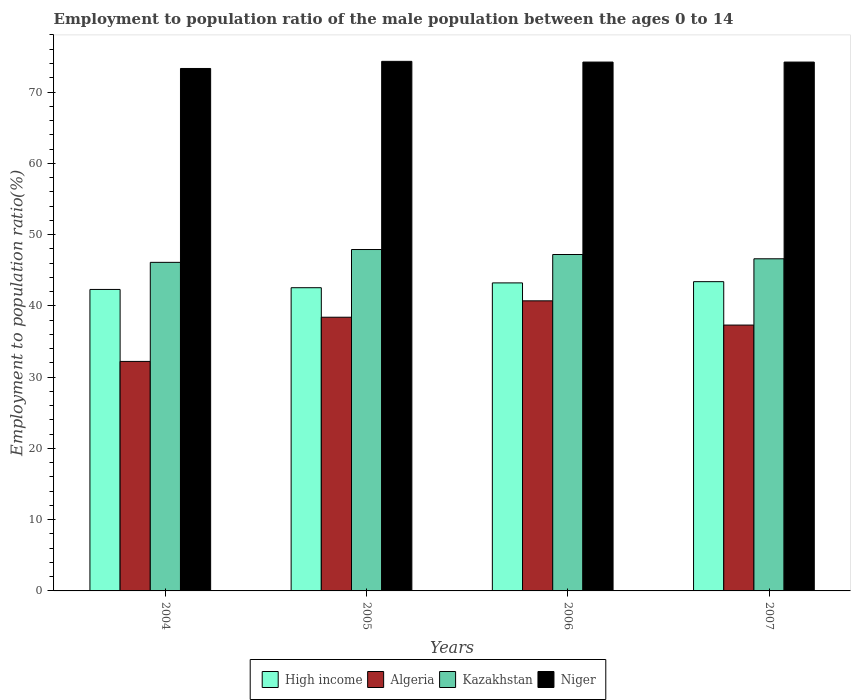How many groups of bars are there?
Provide a short and direct response. 4. Are the number of bars on each tick of the X-axis equal?
Provide a succinct answer. Yes. How many bars are there on the 1st tick from the left?
Provide a short and direct response. 4. How many bars are there on the 1st tick from the right?
Your answer should be compact. 4. In how many cases, is the number of bars for a given year not equal to the number of legend labels?
Provide a succinct answer. 0. What is the employment to population ratio in Kazakhstan in 2007?
Ensure brevity in your answer.  46.6. Across all years, what is the maximum employment to population ratio in Algeria?
Your answer should be very brief. 40.7. Across all years, what is the minimum employment to population ratio in Algeria?
Your answer should be compact. 32.2. In which year was the employment to population ratio in Algeria minimum?
Give a very brief answer. 2004. What is the total employment to population ratio in High income in the graph?
Ensure brevity in your answer.  171.44. What is the difference between the employment to population ratio in High income in 2006 and that in 2007?
Your answer should be compact. -0.17. What is the difference between the employment to population ratio in High income in 2007 and the employment to population ratio in Niger in 2005?
Provide a short and direct response. -30.91. What is the average employment to population ratio in Niger per year?
Keep it short and to the point. 74. In the year 2006, what is the difference between the employment to population ratio in High income and employment to population ratio in Niger?
Provide a short and direct response. -30.98. In how many years, is the employment to population ratio in Niger greater than 36 %?
Keep it short and to the point. 4. What is the ratio of the employment to population ratio in Algeria in 2006 to that in 2007?
Keep it short and to the point. 1.09. Is the employment to population ratio in Algeria in 2004 less than that in 2007?
Offer a terse response. Yes. Is the difference between the employment to population ratio in High income in 2005 and 2006 greater than the difference between the employment to population ratio in Niger in 2005 and 2006?
Offer a very short reply. No. What is the difference between the highest and the second highest employment to population ratio in Niger?
Your answer should be compact. 0.1. What is the difference between the highest and the lowest employment to population ratio in High income?
Provide a short and direct response. 1.09. In how many years, is the employment to population ratio in High income greater than the average employment to population ratio in High income taken over all years?
Give a very brief answer. 2. Is the sum of the employment to population ratio in High income in 2004 and 2006 greater than the maximum employment to population ratio in Kazakhstan across all years?
Offer a very short reply. Yes. What does the 1st bar from the left in 2005 represents?
Provide a short and direct response. High income. What does the 3rd bar from the right in 2006 represents?
Keep it short and to the point. Algeria. Are all the bars in the graph horizontal?
Offer a very short reply. No. How many years are there in the graph?
Provide a succinct answer. 4. Are the values on the major ticks of Y-axis written in scientific E-notation?
Your answer should be compact. No. Does the graph contain any zero values?
Make the answer very short. No. Does the graph contain grids?
Your answer should be very brief. No. How many legend labels are there?
Provide a short and direct response. 4. How are the legend labels stacked?
Keep it short and to the point. Horizontal. What is the title of the graph?
Provide a short and direct response. Employment to population ratio of the male population between the ages 0 to 14. What is the label or title of the Y-axis?
Provide a succinct answer. Employment to population ratio(%). What is the Employment to population ratio(%) in High income in 2004?
Provide a short and direct response. 42.3. What is the Employment to population ratio(%) of Algeria in 2004?
Provide a succinct answer. 32.2. What is the Employment to population ratio(%) of Kazakhstan in 2004?
Offer a terse response. 46.1. What is the Employment to population ratio(%) of Niger in 2004?
Ensure brevity in your answer.  73.3. What is the Employment to population ratio(%) in High income in 2005?
Make the answer very short. 42.54. What is the Employment to population ratio(%) in Algeria in 2005?
Provide a short and direct response. 38.4. What is the Employment to population ratio(%) in Kazakhstan in 2005?
Make the answer very short. 47.9. What is the Employment to population ratio(%) of Niger in 2005?
Give a very brief answer. 74.3. What is the Employment to population ratio(%) of High income in 2006?
Your response must be concise. 43.22. What is the Employment to population ratio(%) in Algeria in 2006?
Give a very brief answer. 40.7. What is the Employment to population ratio(%) in Kazakhstan in 2006?
Provide a succinct answer. 47.2. What is the Employment to population ratio(%) in Niger in 2006?
Offer a very short reply. 74.2. What is the Employment to population ratio(%) of High income in 2007?
Keep it short and to the point. 43.39. What is the Employment to population ratio(%) in Algeria in 2007?
Your answer should be very brief. 37.3. What is the Employment to population ratio(%) of Kazakhstan in 2007?
Give a very brief answer. 46.6. What is the Employment to population ratio(%) in Niger in 2007?
Your answer should be compact. 74.2. Across all years, what is the maximum Employment to population ratio(%) of High income?
Keep it short and to the point. 43.39. Across all years, what is the maximum Employment to population ratio(%) in Algeria?
Provide a succinct answer. 40.7. Across all years, what is the maximum Employment to population ratio(%) of Kazakhstan?
Ensure brevity in your answer.  47.9. Across all years, what is the maximum Employment to population ratio(%) of Niger?
Your answer should be very brief. 74.3. Across all years, what is the minimum Employment to population ratio(%) in High income?
Ensure brevity in your answer.  42.3. Across all years, what is the minimum Employment to population ratio(%) of Algeria?
Provide a succinct answer. 32.2. Across all years, what is the minimum Employment to population ratio(%) in Kazakhstan?
Keep it short and to the point. 46.1. Across all years, what is the minimum Employment to population ratio(%) of Niger?
Give a very brief answer. 73.3. What is the total Employment to population ratio(%) of High income in the graph?
Your answer should be compact. 171.44. What is the total Employment to population ratio(%) of Algeria in the graph?
Your response must be concise. 148.6. What is the total Employment to population ratio(%) of Kazakhstan in the graph?
Offer a very short reply. 187.8. What is the total Employment to population ratio(%) of Niger in the graph?
Offer a terse response. 296. What is the difference between the Employment to population ratio(%) of High income in 2004 and that in 2005?
Your answer should be compact. -0.24. What is the difference between the Employment to population ratio(%) in High income in 2004 and that in 2006?
Ensure brevity in your answer.  -0.92. What is the difference between the Employment to population ratio(%) in Algeria in 2004 and that in 2006?
Keep it short and to the point. -8.5. What is the difference between the Employment to population ratio(%) of Kazakhstan in 2004 and that in 2006?
Offer a terse response. -1.1. What is the difference between the Employment to population ratio(%) in Niger in 2004 and that in 2006?
Ensure brevity in your answer.  -0.9. What is the difference between the Employment to population ratio(%) in High income in 2004 and that in 2007?
Your answer should be compact. -1.09. What is the difference between the Employment to population ratio(%) of Algeria in 2004 and that in 2007?
Make the answer very short. -5.1. What is the difference between the Employment to population ratio(%) in Niger in 2004 and that in 2007?
Provide a short and direct response. -0.9. What is the difference between the Employment to population ratio(%) in High income in 2005 and that in 2006?
Keep it short and to the point. -0.68. What is the difference between the Employment to population ratio(%) of Kazakhstan in 2005 and that in 2006?
Your answer should be compact. 0.7. What is the difference between the Employment to population ratio(%) of Niger in 2005 and that in 2006?
Give a very brief answer. 0.1. What is the difference between the Employment to population ratio(%) of High income in 2005 and that in 2007?
Your answer should be compact. -0.85. What is the difference between the Employment to population ratio(%) in Niger in 2005 and that in 2007?
Provide a succinct answer. 0.1. What is the difference between the Employment to population ratio(%) of High income in 2006 and that in 2007?
Keep it short and to the point. -0.17. What is the difference between the Employment to population ratio(%) in Algeria in 2006 and that in 2007?
Offer a terse response. 3.4. What is the difference between the Employment to population ratio(%) of Kazakhstan in 2006 and that in 2007?
Provide a short and direct response. 0.6. What is the difference between the Employment to population ratio(%) of Niger in 2006 and that in 2007?
Keep it short and to the point. 0. What is the difference between the Employment to population ratio(%) in High income in 2004 and the Employment to population ratio(%) in Algeria in 2005?
Offer a very short reply. 3.9. What is the difference between the Employment to population ratio(%) in High income in 2004 and the Employment to population ratio(%) in Kazakhstan in 2005?
Provide a short and direct response. -5.6. What is the difference between the Employment to population ratio(%) in High income in 2004 and the Employment to population ratio(%) in Niger in 2005?
Provide a short and direct response. -32. What is the difference between the Employment to population ratio(%) of Algeria in 2004 and the Employment to population ratio(%) of Kazakhstan in 2005?
Make the answer very short. -15.7. What is the difference between the Employment to population ratio(%) in Algeria in 2004 and the Employment to population ratio(%) in Niger in 2005?
Your answer should be compact. -42.1. What is the difference between the Employment to population ratio(%) of Kazakhstan in 2004 and the Employment to population ratio(%) of Niger in 2005?
Provide a short and direct response. -28.2. What is the difference between the Employment to population ratio(%) in High income in 2004 and the Employment to population ratio(%) in Algeria in 2006?
Make the answer very short. 1.6. What is the difference between the Employment to population ratio(%) of High income in 2004 and the Employment to population ratio(%) of Kazakhstan in 2006?
Your answer should be very brief. -4.9. What is the difference between the Employment to population ratio(%) in High income in 2004 and the Employment to population ratio(%) in Niger in 2006?
Give a very brief answer. -31.9. What is the difference between the Employment to population ratio(%) of Algeria in 2004 and the Employment to population ratio(%) of Kazakhstan in 2006?
Give a very brief answer. -15. What is the difference between the Employment to population ratio(%) in Algeria in 2004 and the Employment to population ratio(%) in Niger in 2006?
Your answer should be very brief. -42. What is the difference between the Employment to population ratio(%) in Kazakhstan in 2004 and the Employment to population ratio(%) in Niger in 2006?
Your response must be concise. -28.1. What is the difference between the Employment to population ratio(%) in High income in 2004 and the Employment to population ratio(%) in Algeria in 2007?
Make the answer very short. 5. What is the difference between the Employment to population ratio(%) in High income in 2004 and the Employment to population ratio(%) in Kazakhstan in 2007?
Give a very brief answer. -4.3. What is the difference between the Employment to population ratio(%) in High income in 2004 and the Employment to population ratio(%) in Niger in 2007?
Make the answer very short. -31.9. What is the difference between the Employment to population ratio(%) in Algeria in 2004 and the Employment to population ratio(%) in Kazakhstan in 2007?
Ensure brevity in your answer.  -14.4. What is the difference between the Employment to population ratio(%) in Algeria in 2004 and the Employment to population ratio(%) in Niger in 2007?
Make the answer very short. -42. What is the difference between the Employment to population ratio(%) in Kazakhstan in 2004 and the Employment to population ratio(%) in Niger in 2007?
Ensure brevity in your answer.  -28.1. What is the difference between the Employment to population ratio(%) in High income in 2005 and the Employment to population ratio(%) in Algeria in 2006?
Give a very brief answer. 1.84. What is the difference between the Employment to population ratio(%) in High income in 2005 and the Employment to population ratio(%) in Kazakhstan in 2006?
Make the answer very short. -4.66. What is the difference between the Employment to population ratio(%) in High income in 2005 and the Employment to population ratio(%) in Niger in 2006?
Offer a very short reply. -31.66. What is the difference between the Employment to population ratio(%) in Algeria in 2005 and the Employment to population ratio(%) in Niger in 2006?
Your response must be concise. -35.8. What is the difference between the Employment to population ratio(%) of Kazakhstan in 2005 and the Employment to population ratio(%) of Niger in 2006?
Your response must be concise. -26.3. What is the difference between the Employment to population ratio(%) of High income in 2005 and the Employment to population ratio(%) of Algeria in 2007?
Your answer should be very brief. 5.24. What is the difference between the Employment to population ratio(%) of High income in 2005 and the Employment to population ratio(%) of Kazakhstan in 2007?
Provide a short and direct response. -4.06. What is the difference between the Employment to population ratio(%) of High income in 2005 and the Employment to population ratio(%) of Niger in 2007?
Give a very brief answer. -31.66. What is the difference between the Employment to population ratio(%) of Algeria in 2005 and the Employment to population ratio(%) of Kazakhstan in 2007?
Offer a terse response. -8.2. What is the difference between the Employment to population ratio(%) of Algeria in 2005 and the Employment to population ratio(%) of Niger in 2007?
Give a very brief answer. -35.8. What is the difference between the Employment to population ratio(%) of Kazakhstan in 2005 and the Employment to population ratio(%) of Niger in 2007?
Offer a terse response. -26.3. What is the difference between the Employment to population ratio(%) of High income in 2006 and the Employment to population ratio(%) of Algeria in 2007?
Ensure brevity in your answer.  5.92. What is the difference between the Employment to population ratio(%) of High income in 2006 and the Employment to population ratio(%) of Kazakhstan in 2007?
Your response must be concise. -3.38. What is the difference between the Employment to population ratio(%) in High income in 2006 and the Employment to population ratio(%) in Niger in 2007?
Your answer should be compact. -30.98. What is the difference between the Employment to population ratio(%) in Algeria in 2006 and the Employment to population ratio(%) in Niger in 2007?
Give a very brief answer. -33.5. What is the difference between the Employment to population ratio(%) of Kazakhstan in 2006 and the Employment to population ratio(%) of Niger in 2007?
Provide a short and direct response. -27. What is the average Employment to population ratio(%) in High income per year?
Make the answer very short. 42.86. What is the average Employment to population ratio(%) in Algeria per year?
Your answer should be compact. 37.15. What is the average Employment to population ratio(%) in Kazakhstan per year?
Your response must be concise. 46.95. What is the average Employment to population ratio(%) of Niger per year?
Provide a succinct answer. 74. In the year 2004, what is the difference between the Employment to population ratio(%) in High income and Employment to population ratio(%) in Algeria?
Give a very brief answer. 10.1. In the year 2004, what is the difference between the Employment to population ratio(%) in High income and Employment to population ratio(%) in Kazakhstan?
Your answer should be compact. -3.8. In the year 2004, what is the difference between the Employment to population ratio(%) of High income and Employment to population ratio(%) of Niger?
Offer a very short reply. -31. In the year 2004, what is the difference between the Employment to population ratio(%) in Algeria and Employment to population ratio(%) in Niger?
Give a very brief answer. -41.1. In the year 2004, what is the difference between the Employment to population ratio(%) in Kazakhstan and Employment to population ratio(%) in Niger?
Provide a succinct answer. -27.2. In the year 2005, what is the difference between the Employment to population ratio(%) in High income and Employment to population ratio(%) in Algeria?
Your answer should be compact. 4.14. In the year 2005, what is the difference between the Employment to population ratio(%) of High income and Employment to population ratio(%) of Kazakhstan?
Make the answer very short. -5.36. In the year 2005, what is the difference between the Employment to population ratio(%) in High income and Employment to population ratio(%) in Niger?
Your answer should be very brief. -31.76. In the year 2005, what is the difference between the Employment to population ratio(%) of Algeria and Employment to population ratio(%) of Kazakhstan?
Your response must be concise. -9.5. In the year 2005, what is the difference between the Employment to population ratio(%) in Algeria and Employment to population ratio(%) in Niger?
Ensure brevity in your answer.  -35.9. In the year 2005, what is the difference between the Employment to population ratio(%) in Kazakhstan and Employment to population ratio(%) in Niger?
Provide a succinct answer. -26.4. In the year 2006, what is the difference between the Employment to population ratio(%) of High income and Employment to population ratio(%) of Algeria?
Your response must be concise. 2.52. In the year 2006, what is the difference between the Employment to population ratio(%) of High income and Employment to population ratio(%) of Kazakhstan?
Make the answer very short. -3.98. In the year 2006, what is the difference between the Employment to population ratio(%) in High income and Employment to population ratio(%) in Niger?
Provide a succinct answer. -30.98. In the year 2006, what is the difference between the Employment to population ratio(%) of Algeria and Employment to population ratio(%) of Niger?
Give a very brief answer. -33.5. In the year 2006, what is the difference between the Employment to population ratio(%) of Kazakhstan and Employment to population ratio(%) of Niger?
Your answer should be very brief. -27. In the year 2007, what is the difference between the Employment to population ratio(%) in High income and Employment to population ratio(%) in Algeria?
Offer a terse response. 6.09. In the year 2007, what is the difference between the Employment to population ratio(%) of High income and Employment to population ratio(%) of Kazakhstan?
Provide a short and direct response. -3.21. In the year 2007, what is the difference between the Employment to population ratio(%) of High income and Employment to population ratio(%) of Niger?
Offer a very short reply. -30.81. In the year 2007, what is the difference between the Employment to population ratio(%) of Algeria and Employment to population ratio(%) of Kazakhstan?
Ensure brevity in your answer.  -9.3. In the year 2007, what is the difference between the Employment to population ratio(%) in Algeria and Employment to population ratio(%) in Niger?
Ensure brevity in your answer.  -36.9. In the year 2007, what is the difference between the Employment to population ratio(%) in Kazakhstan and Employment to population ratio(%) in Niger?
Your answer should be compact. -27.6. What is the ratio of the Employment to population ratio(%) of High income in 2004 to that in 2005?
Give a very brief answer. 0.99. What is the ratio of the Employment to population ratio(%) of Algeria in 2004 to that in 2005?
Give a very brief answer. 0.84. What is the ratio of the Employment to population ratio(%) of Kazakhstan in 2004 to that in 2005?
Provide a succinct answer. 0.96. What is the ratio of the Employment to population ratio(%) of Niger in 2004 to that in 2005?
Provide a short and direct response. 0.99. What is the ratio of the Employment to population ratio(%) of High income in 2004 to that in 2006?
Ensure brevity in your answer.  0.98. What is the ratio of the Employment to population ratio(%) in Algeria in 2004 to that in 2006?
Provide a succinct answer. 0.79. What is the ratio of the Employment to population ratio(%) in Kazakhstan in 2004 to that in 2006?
Provide a short and direct response. 0.98. What is the ratio of the Employment to population ratio(%) of Niger in 2004 to that in 2006?
Your answer should be very brief. 0.99. What is the ratio of the Employment to population ratio(%) of High income in 2004 to that in 2007?
Provide a short and direct response. 0.97. What is the ratio of the Employment to population ratio(%) of Algeria in 2004 to that in 2007?
Offer a terse response. 0.86. What is the ratio of the Employment to population ratio(%) of Kazakhstan in 2004 to that in 2007?
Keep it short and to the point. 0.99. What is the ratio of the Employment to population ratio(%) in Niger in 2004 to that in 2007?
Give a very brief answer. 0.99. What is the ratio of the Employment to population ratio(%) of High income in 2005 to that in 2006?
Keep it short and to the point. 0.98. What is the ratio of the Employment to population ratio(%) of Algeria in 2005 to that in 2006?
Offer a very short reply. 0.94. What is the ratio of the Employment to population ratio(%) in Kazakhstan in 2005 to that in 2006?
Your response must be concise. 1.01. What is the ratio of the Employment to population ratio(%) of Niger in 2005 to that in 2006?
Provide a succinct answer. 1. What is the ratio of the Employment to population ratio(%) of High income in 2005 to that in 2007?
Provide a succinct answer. 0.98. What is the ratio of the Employment to population ratio(%) in Algeria in 2005 to that in 2007?
Your answer should be very brief. 1.03. What is the ratio of the Employment to population ratio(%) of Kazakhstan in 2005 to that in 2007?
Provide a short and direct response. 1.03. What is the ratio of the Employment to population ratio(%) in Niger in 2005 to that in 2007?
Provide a succinct answer. 1. What is the ratio of the Employment to population ratio(%) in High income in 2006 to that in 2007?
Provide a succinct answer. 1. What is the ratio of the Employment to population ratio(%) of Algeria in 2006 to that in 2007?
Keep it short and to the point. 1.09. What is the ratio of the Employment to population ratio(%) of Kazakhstan in 2006 to that in 2007?
Your answer should be compact. 1.01. What is the difference between the highest and the second highest Employment to population ratio(%) of High income?
Offer a very short reply. 0.17. What is the difference between the highest and the second highest Employment to population ratio(%) of Kazakhstan?
Offer a very short reply. 0.7. What is the difference between the highest and the second highest Employment to population ratio(%) of Niger?
Make the answer very short. 0.1. What is the difference between the highest and the lowest Employment to population ratio(%) in High income?
Keep it short and to the point. 1.09. 